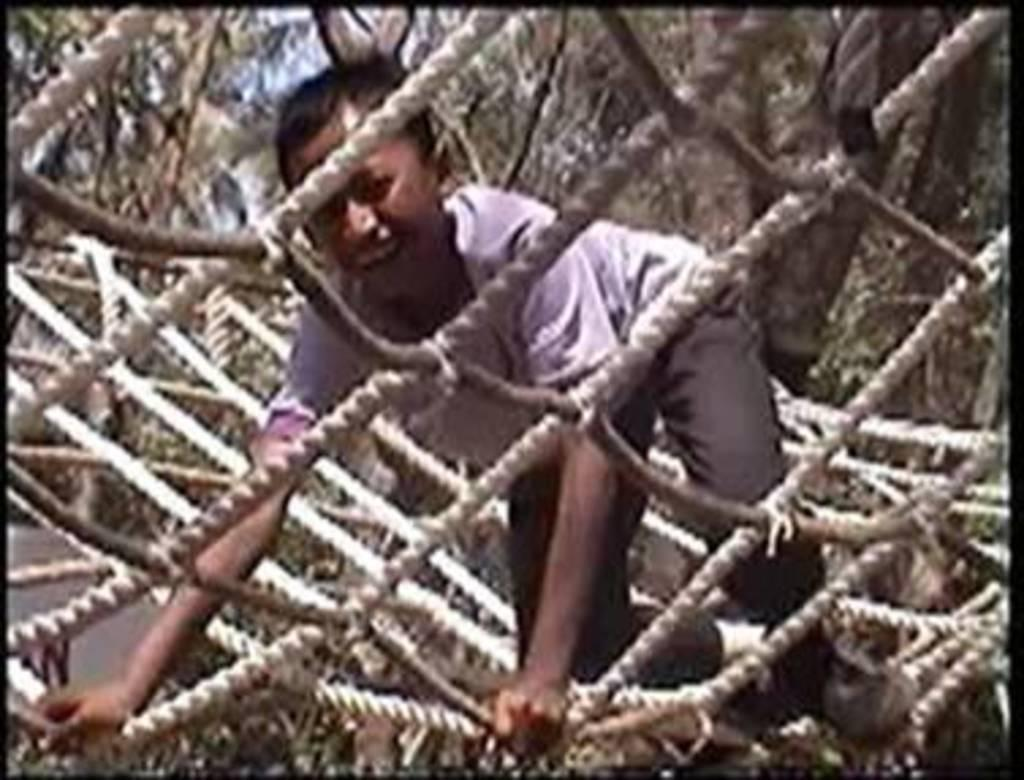What is the person in the image doing? There is a person on a net in the image. What can be seen in the background of the image? There are trees visible in the background of the image. What book is the person reading while on the net in the image? There is no book or reading activity present in the image. How many bells can be seen hanging from the net in the image? There are no bells present in the image. Are there any spiders visible on the net in the image? There is no mention of spiders in the image. 